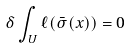<formula> <loc_0><loc_0><loc_500><loc_500>\delta \int _ { U } \ell ( \bar { \sigma } ( x ) ) = 0</formula> 